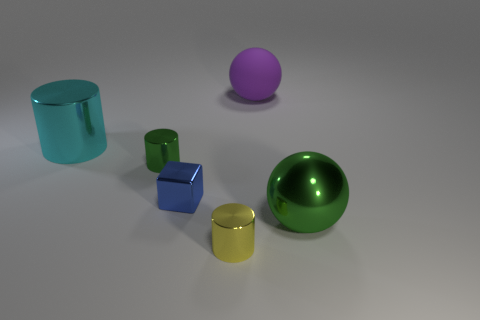Subtract all yellow cylinders. How many cylinders are left? 2 Add 2 purple things. How many objects exist? 8 Subtract all purple balls. How many balls are left? 1 Subtract 1 cylinders. How many cylinders are left? 2 Subtract all gray cylinders. Subtract all cyan blocks. How many cylinders are left? 3 Add 4 big green balls. How many big green balls are left? 5 Add 4 red metal cylinders. How many red metal cylinders exist? 4 Subtract 0 red blocks. How many objects are left? 6 Subtract all spheres. How many objects are left? 4 Subtract all tiny green metallic objects. Subtract all blue cubes. How many objects are left? 4 